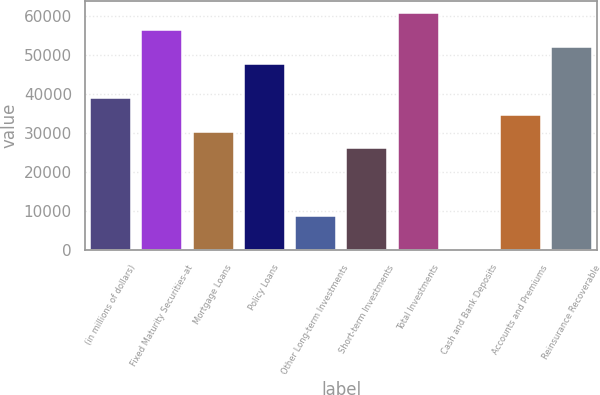Convert chart. <chart><loc_0><loc_0><loc_500><loc_500><bar_chart><fcel>(in millions of dollars)<fcel>Fixed Maturity Securities-at<fcel>Mortgage Loans<fcel>Policy Loans<fcel>Other Long-term Investments<fcel>Short-term Investments<fcel>Total Investments<fcel>Cash and Bank Deposits<fcel>Accounts and Premiums<fcel>Reinsurance Recoverable<nl><fcel>38973<fcel>56262.5<fcel>30328.3<fcel>47617.8<fcel>8716.36<fcel>26005.9<fcel>60584.9<fcel>71.6<fcel>34650.6<fcel>51940.2<nl></chart> 